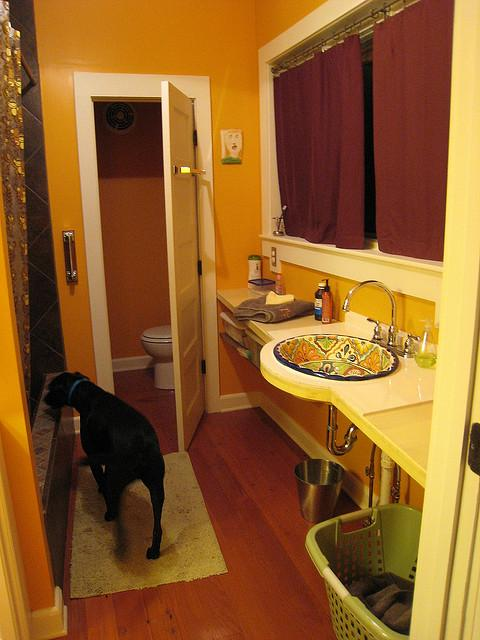What type of dog is this? Please explain your reasoning. black lab. The dog in the bathroom is a large black labrador. 